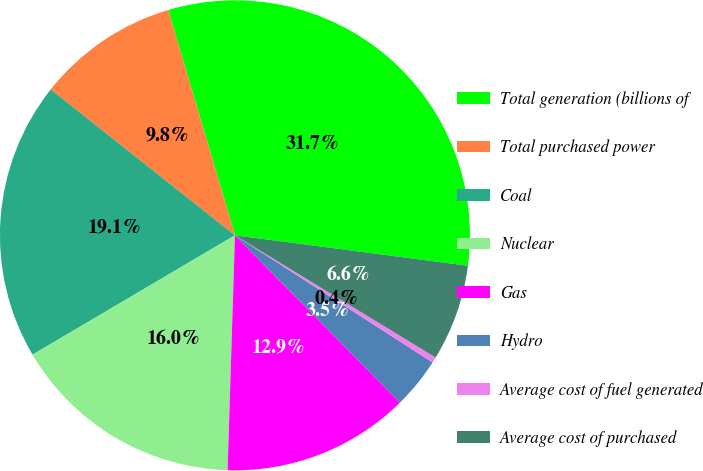<chart> <loc_0><loc_0><loc_500><loc_500><pie_chart><fcel>Total generation (billions of<fcel>Total purchased power<fcel>Coal<fcel>Nuclear<fcel>Gas<fcel>Hydro<fcel>Average cost of fuel generated<fcel>Average cost of purchased<nl><fcel>31.65%<fcel>9.76%<fcel>19.14%<fcel>16.02%<fcel>12.89%<fcel>3.51%<fcel>0.39%<fcel>6.64%<nl></chart> 